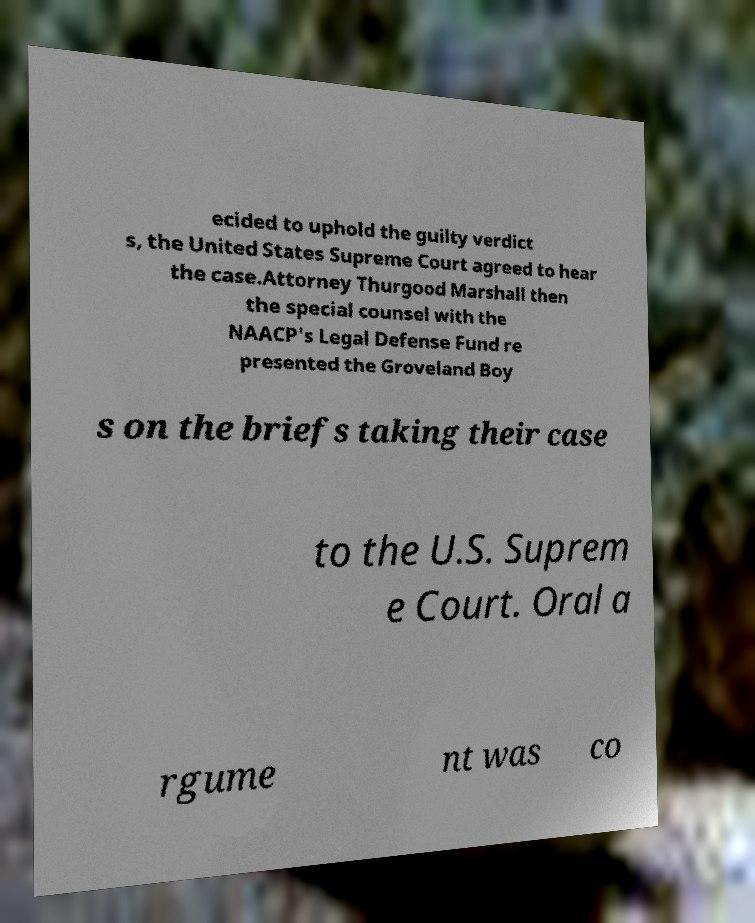Can you read and provide the text displayed in the image?This photo seems to have some interesting text. Can you extract and type it out for me? ecided to uphold the guilty verdict s, the United States Supreme Court agreed to hear the case.Attorney Thurgood Marshall then the special counsel with the NAACP's Legal Defense Fund re presented the Groveland Boy s on the briefs taking their case to the U.S. Suprem e Court. Oral a rgume nt was co 